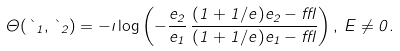<formula> <loc_0><loc_0><loc_500><loc_500>\Theta ( \theta _ { 1 } , \theta _ { 2 } ) = - \imath \log \left ( - \frac { e _ { 2 } } { e _ { 1 } } \, \frac { ( 1 + 1 / e ) e _ { 2 } - \epsilon } { ( 1 + 1 / e ) e _ { 1 } - \epsilon } \right ) , \, E \neq 0 .</formula> 